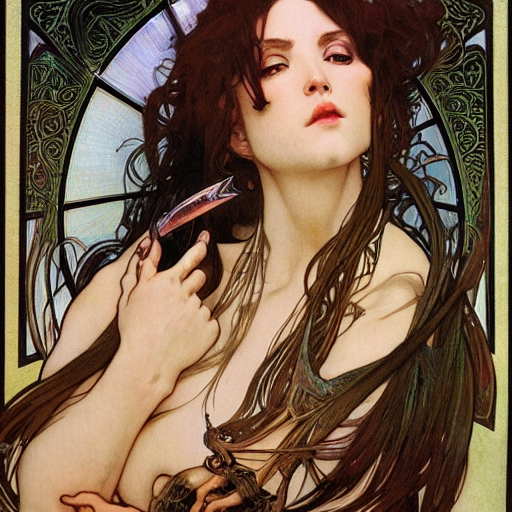What mood does the image evoke? The image evokes a somewhat mystical and introspective mood. The color palette is subdued yet rich, creating a sense of depth and emotion. The subject's pose and expression also contribute to a mysterious atmosphere, leaving viewers with a sense of wonder and contemplation. What elements contribute to the art nouveau influence? Traditional elements such as the use of flowing lines, stylized organic forms, and meticulous ornamentation contribute to the art nouveau influence. Notice how the curved lines mimic the natural forms of plants and the subject's flowing hair, while the intricate patterns in the background further enhance the art style. 